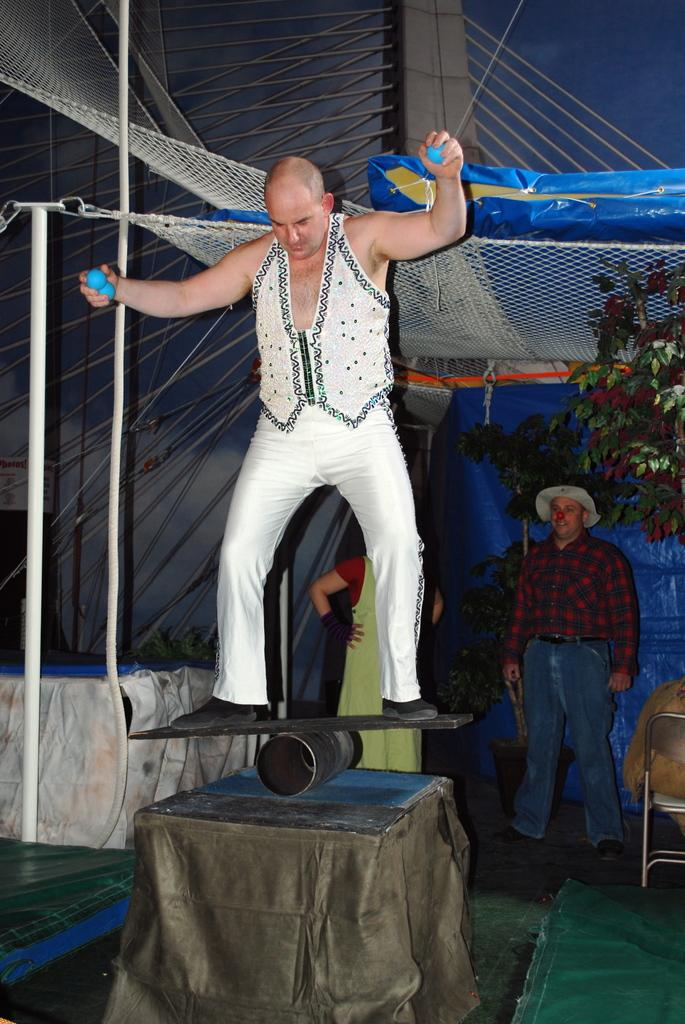What is the main activity of the person in the image? The person is performing in the image. What is the person holding while performing? The person is holding balls. Are there any other people visible in the image? Yes, there are two people standing at the back. What type of work is the ant performing in the image? There is no ant present in the image, so it is not possible to determine what type of work it might be performing. 